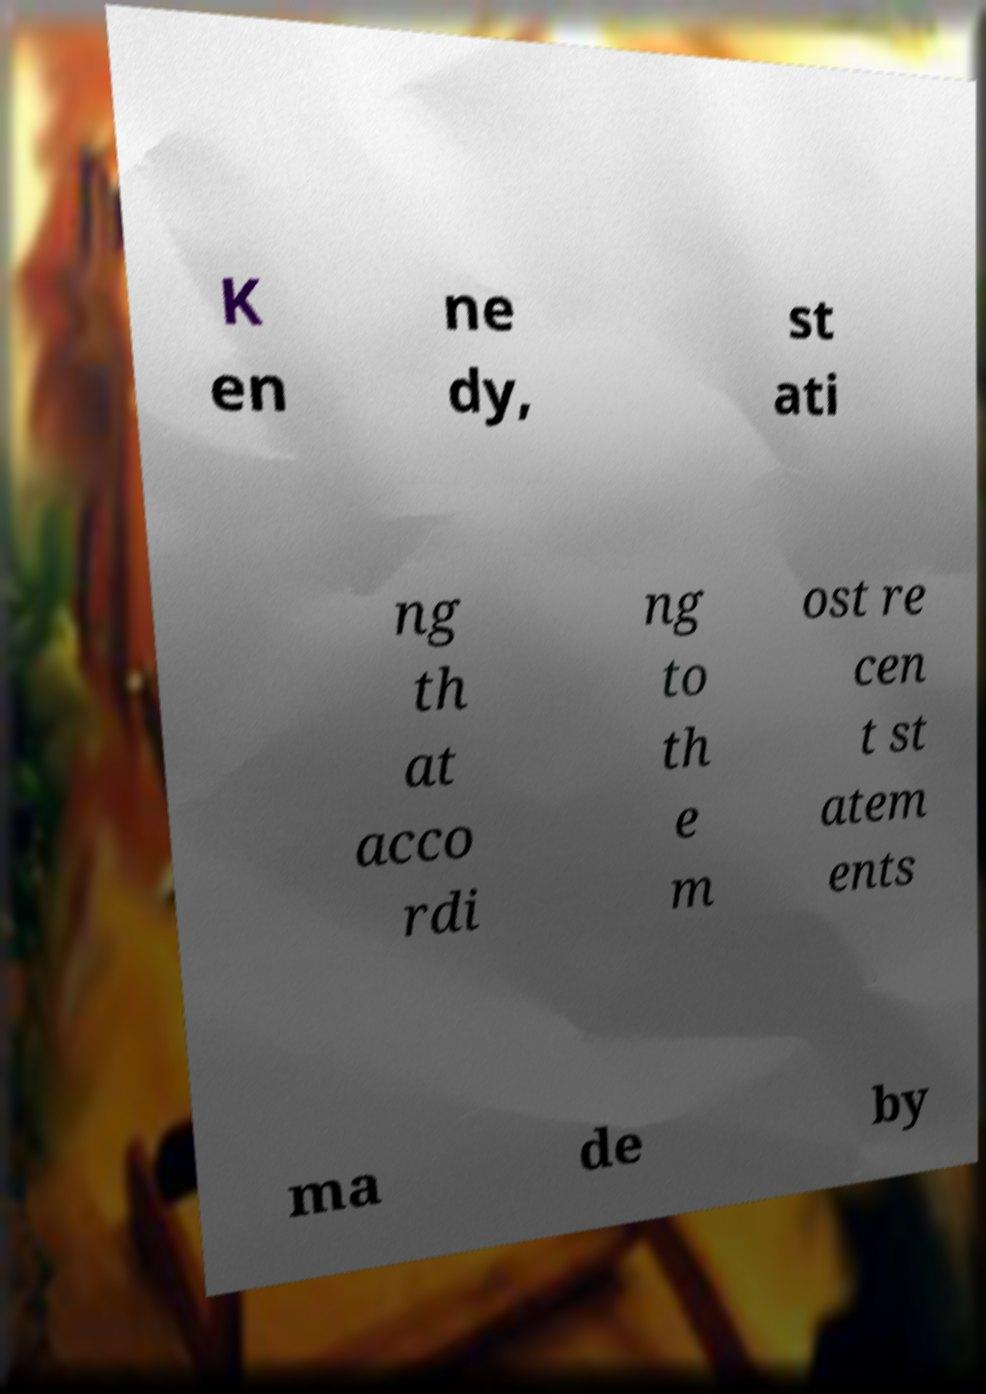Can you accurately transcribe the text from the provided image for me? K en ne dy, st ati ng th at acco rdi ng to th e m ost re cen t st atem ents ma de by 